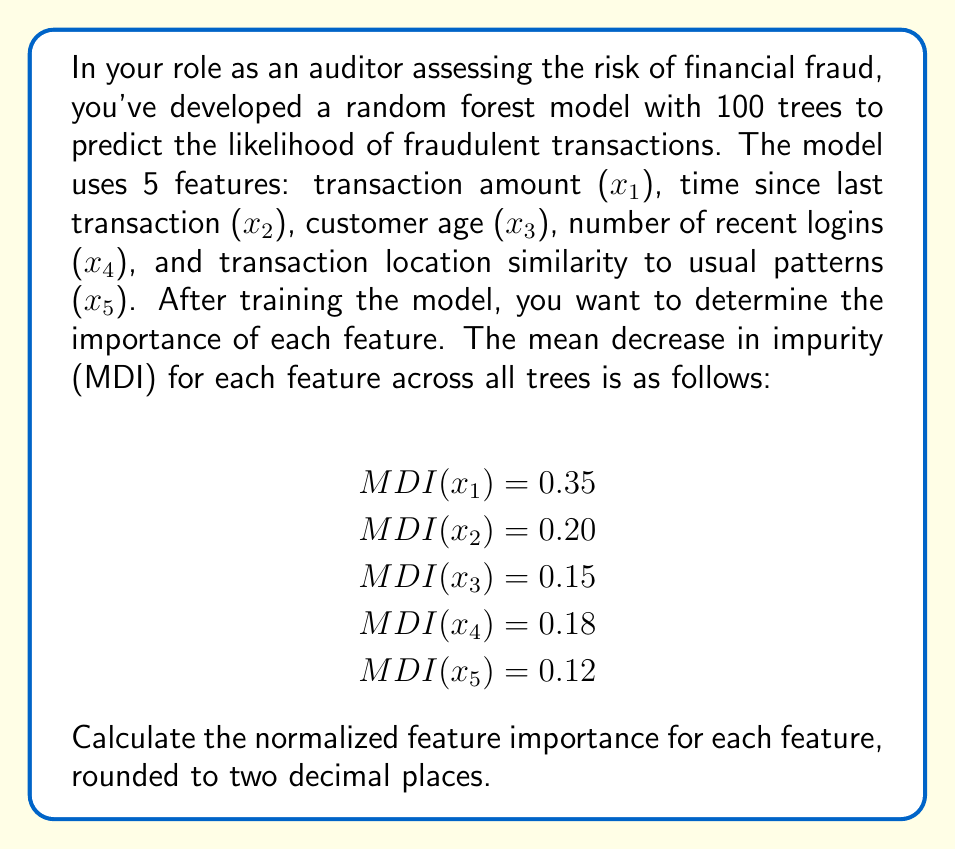Can you answer this question? To calculate the normalized feature importance, we need to follow these steps:

1. Sum up all the MDI values:
   $$\text{Total MDI} = 0.35 + 0.20 + 0.15 + 0.18 + 0.12 = 1.00$$

2. Calculate the normalized importance for each feature by dividing its MDI by the total MDI:

   For $x_1$ (transaction amount):
   $$\text{Normalized Importance}(x_1) = \frac{0.35}{1.00} = 0.35$$

   For $x_2$ (time since last transaction):
   $$\text{Normalized Importance}(x_2) = \frac{0.20}{1.00} = 0.20$$

   For $x_3$ (customer age):
   $$\text{Normalized Importance}(x_3) = \frac{0.15}{1.00} = 0.15$$

   For $x_4$ (number of recent logins):
   $$\text{Normalized Importance}(x_4) = \frac{0.18}{1.00} = 0.18$$

   For $x_5$ (transaction location similarity):
   $$\text{Normalized Importance}(x_5) = \frac{0.12}{1.00} = 0.12$$

3. Round each value to two decimal places (which doesn't change any values in this case).

The normalized feature importance represents the relative importance of each feature in the random forest model for predicting fraudulent transactions. Higher values indicate greater importance in the model's decision-making process.
Answer: The normalized feature importance for each feature, rounded to two decimal places:

$$\begin{align*}
x_1 \text{ (transaction amount)}: &0.35 \\
x_2 \text{ (time since last transaction)}: &0.20 \\
x_3 \text{ (customer age)}: &0.15 \\
x_4 \text{ (number of recent logins)}: &0.18 \\
x_5 \text{ (transaction location similarity)}: &0.12
\end{align*}$$ 